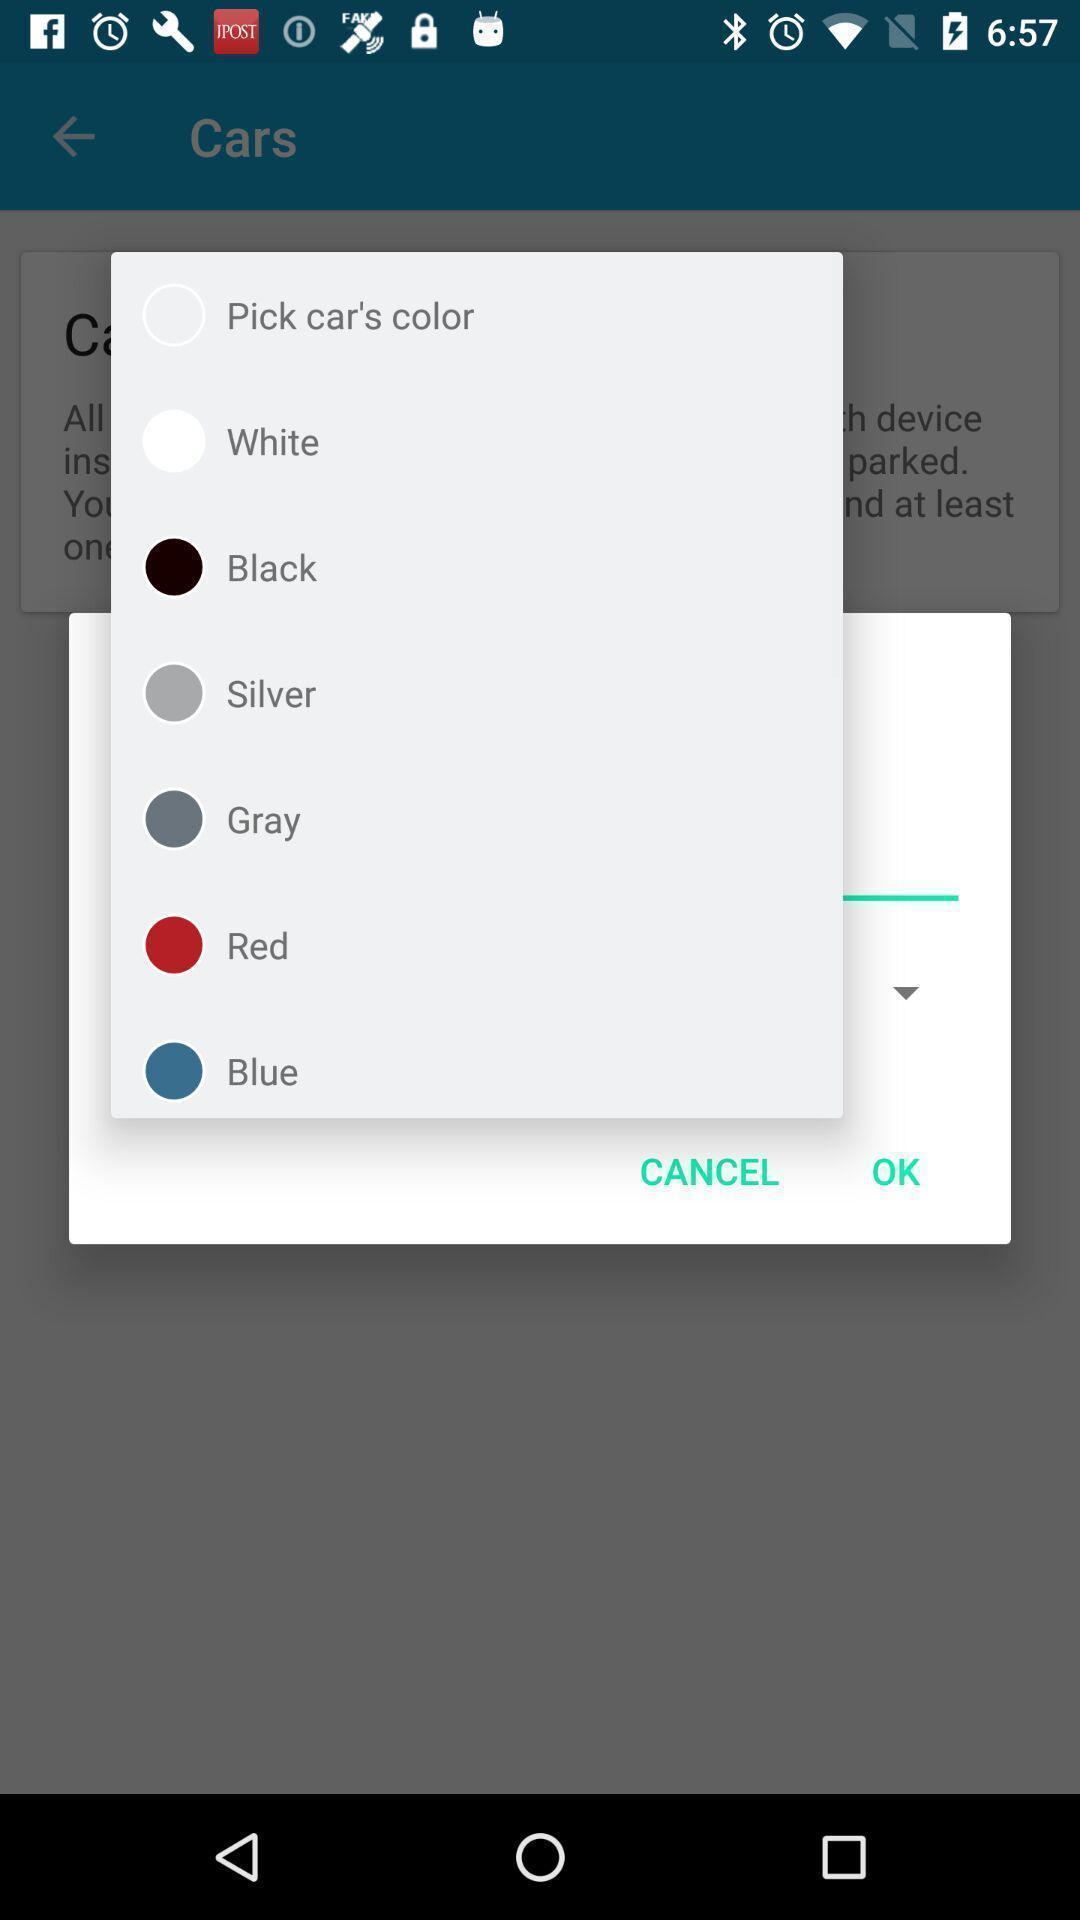Describe the content in this image. Popup of various colors to select. 